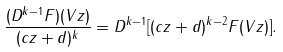Convert formula to latex. <formula><loc_0><loc_0><loc_500><loc_500>\frac { ( D ^ { k - 1 } F ) ( V z ) } { ( c z + d ) ^ { k } } = D ^ { k - 1 } [ ( c z + d ) ^ { k - 2 } F ( V z ) ] .</formula> 